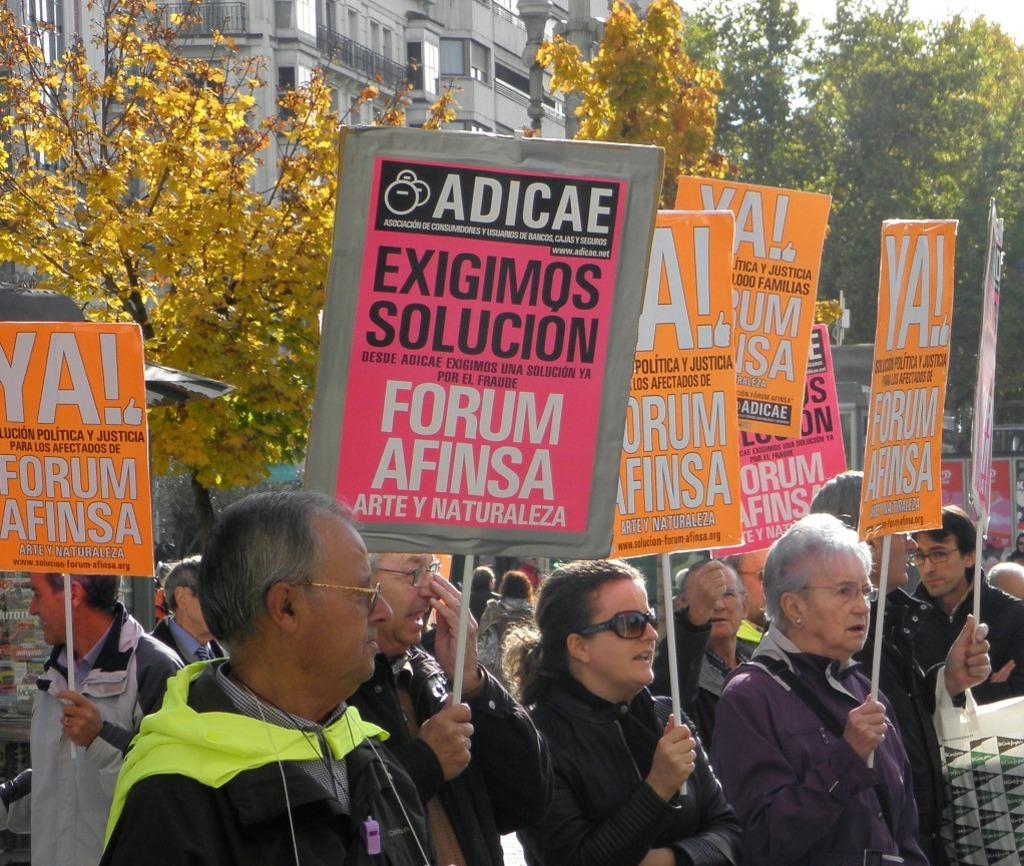What are the people in the image doing? The people in the image are standing and holding placards. What can be seen in the background of the image? There are trees and buildings visible in the background of the image. What type of heat is being generated by the substance in the image? There is no substance or heat present in the image; it features people holding placards with trees and buildings in the background. 